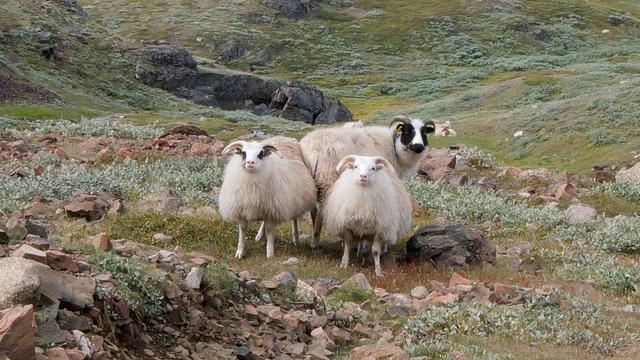What are these animals called? Please explain your reasoning. sheep. The animals have horns and wool. they are not cows, deer, or dogs. 